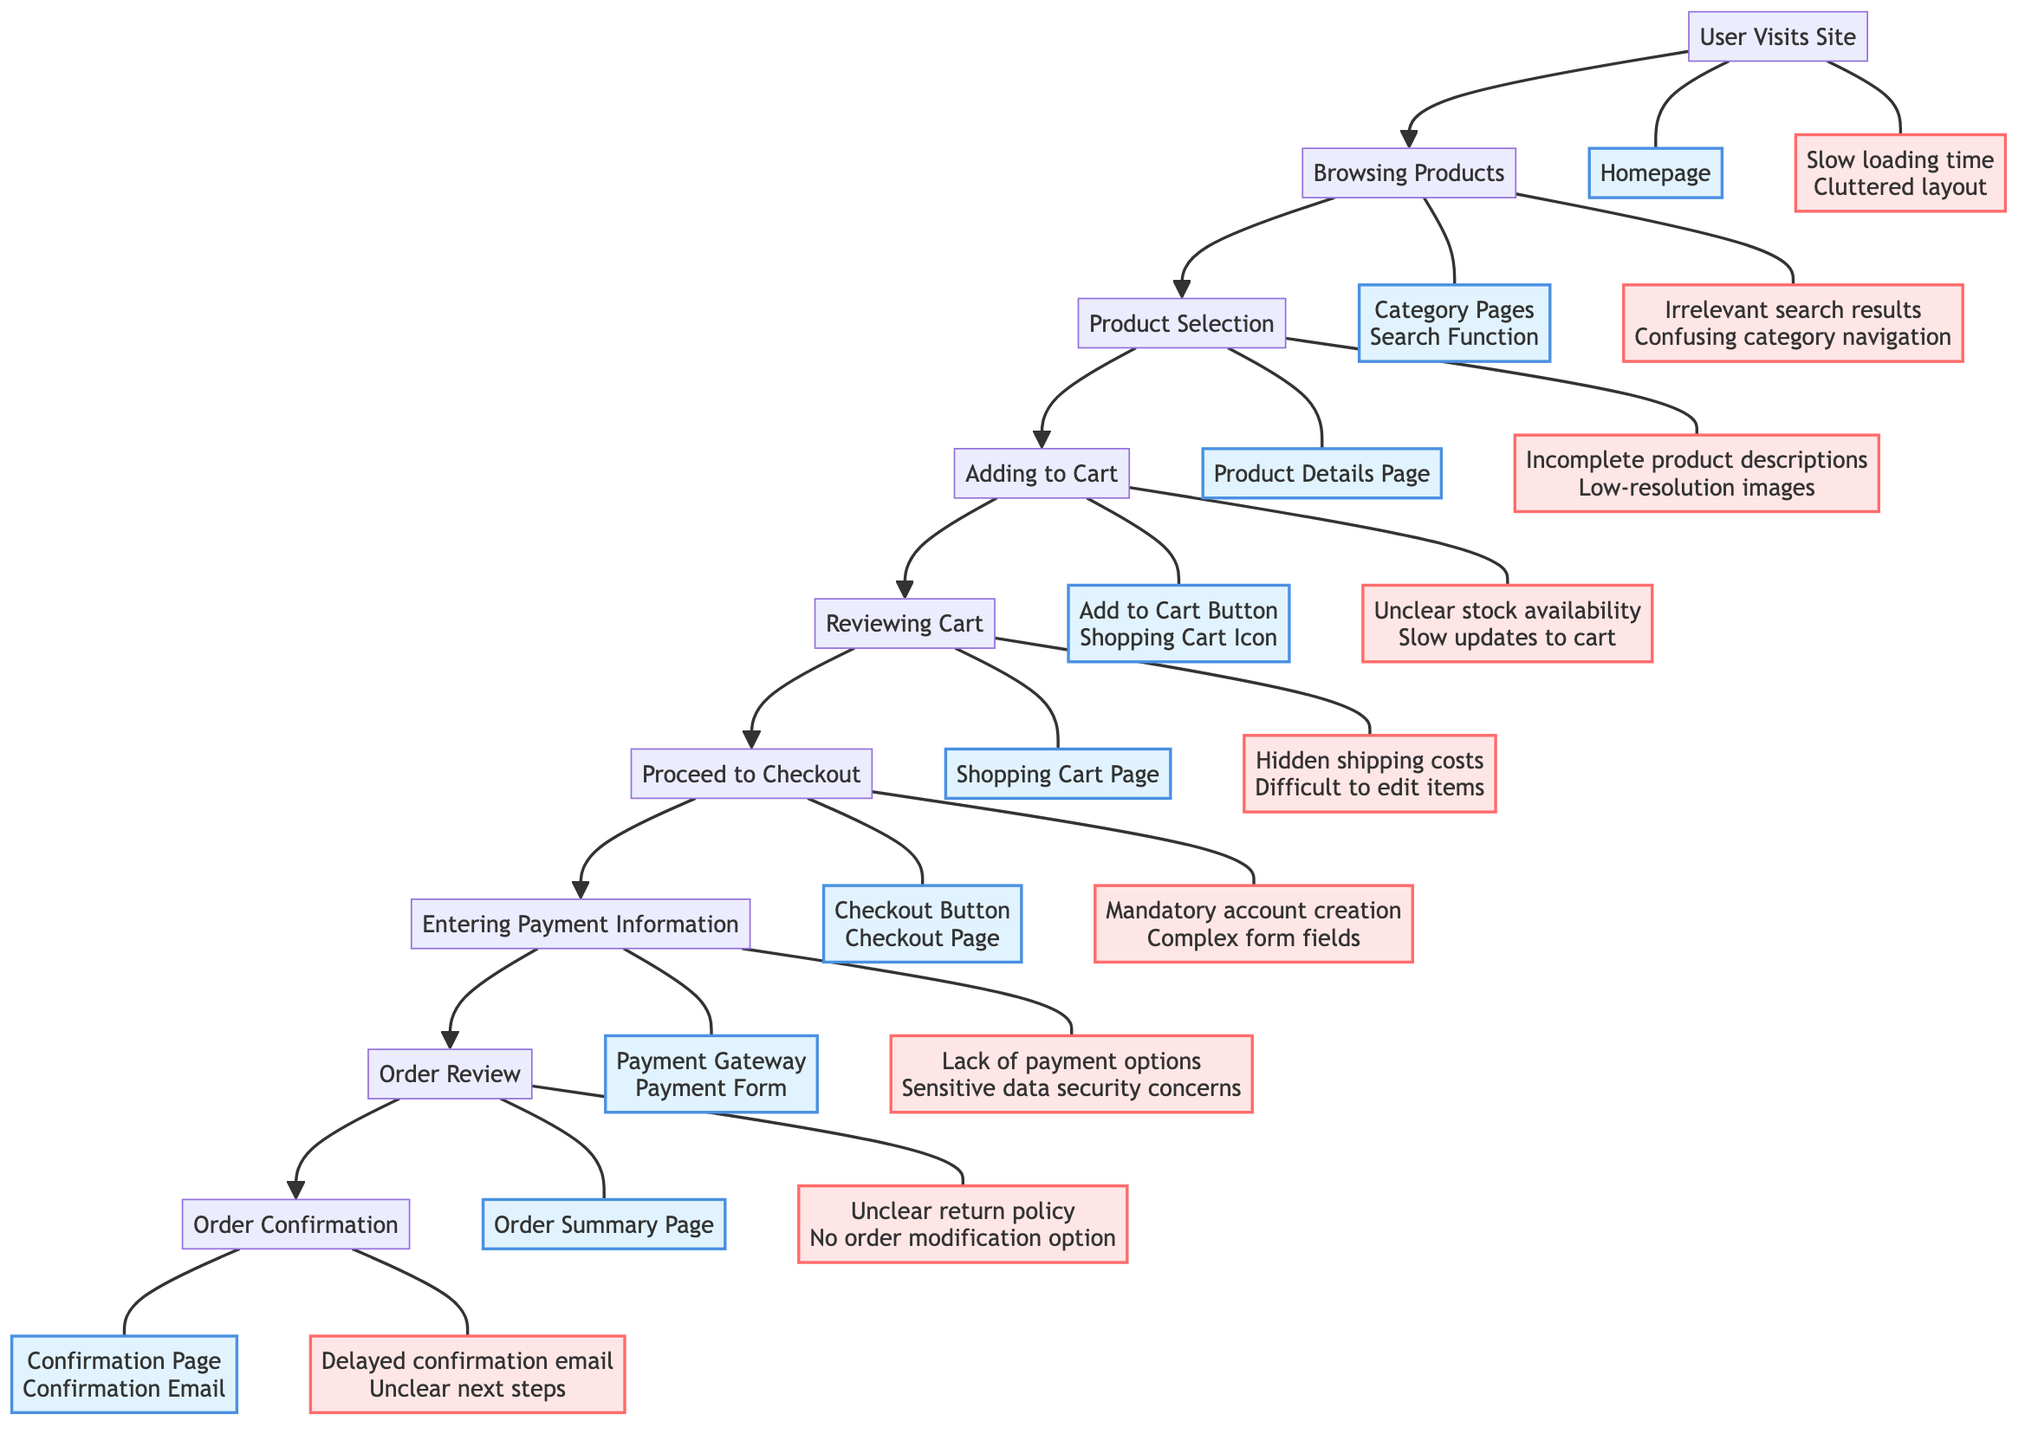What is the first touchpoint in the purchase journey? The diagram indicates that the first touchpoint that users encounter is the "Homepage," which is associated with the "User Visits Site" step.
Answer: Homepage How many pain points are associated with entering payment information? From the diagram, the "Entering Payment Information" node lists two pain points: "Lack of payment options" and "Sensitive data security concerns."
Answer: 2 What is the last step in the e-commerce checkout process? The diagram outlines that the final step is "Order Confirmation," which follows the "Order Review" phase.
Answer: Order Confirmation Identify the pain point related to reviewing the cart. According to the purchase journey, the pain points related to "Reviewing Cart" include "Hidden shipping costs" and "Difficult to edit items." The specific pain point highlighted is "Hidden shipping costs."
Answer: Hidden shipping costs Which step comes just before the "Proceed to Checkout"? The flow of the diagram shows that the step preceding "Proceed to Checkout" is "Reviewing Cart," indicating that users must first review their cart items.
Answer: Reviewing Cart What is the relationship between "Adding to Cart" and "Product Selection"? The diagram depicts a direct relationship, as "Product Selection" must occur before "Adding to Cart," indicating a sequential process in the user journey.
Answer: Sequential process What touchpoint is related to the order review process? The diagram identifies the "Order Summary Page" as the touchpoint associated with "Order Review," indicating where users can review their order details.
Answer: Order Summary Page How many total steps are there in the purchase journey? Upon reviewing the diagram, it shows that there are nine steps from "User Visits Site" to "Order Confirmation."
Answer: 9 What is the pain point related to the checkout button? As per the diagram, the pain point associated with "Proceed to Checkout," which includes the "Checkout Button," is "Mandatory account creation."
Answer: Mandatory account creation 